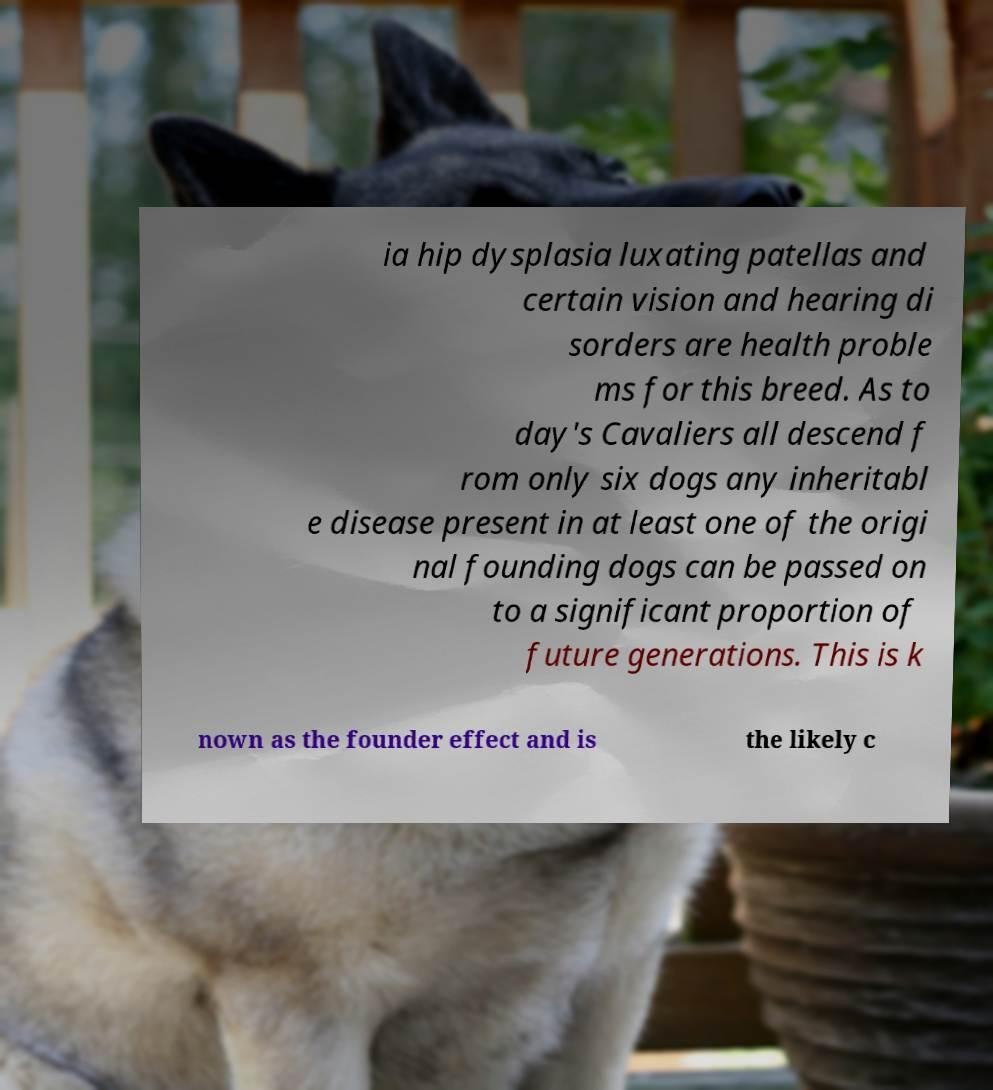For documentation purposes, I need the text within this image transcribed. Could you provide that? ia hip dysplasia luxating patellas and certain vision and hearing di sorders are health proble ms for this breed. As to day's Cavaliers all descend f rom only six dogs any inheritabl e disease present in at least one of the origi nal founding dogs can be passed on to a significant proportion of future generations. This is k nown as the founder effect and is the likely c 